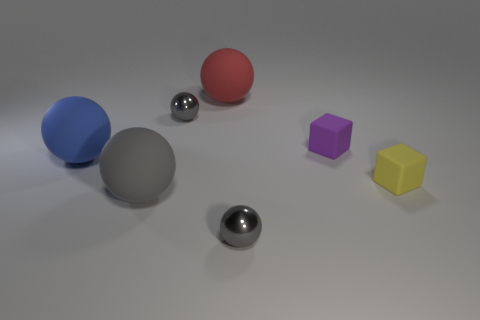Are there any small gray shiny balls in front of the big blue rubber thing?
Offer a very short reply. Yes. Is there any other thing that has the same size as the purple matte object?
Provide a short and direct response. Yes. What color is the other tiny block that is made of the same material as the tiny purple cube?
Offer a terse response. Yellow. Does the shiny ball in front of the big gray ball have the same color as the large object in front of the tiny yellow cube?
Give a very brief answer. Yes. What number of spheres are either big rubber things or small purple rubber things?
Offer a very short reply. 3. Is the number of large balls that are in front of the large blue thing the same as the number of small purple rubber blocks?
Offer a terse response. Yes. There is a tiny gray sphere to the left of the large matte thing that is behind the small gray shiny sphere behind the blue matte ball; what is its material?
Make the answer very short. Metal. How many things are big objects that are on the right side of the blue matte thing or blue rubber things?
Provide a succinct answer. 3. What number of things are either large spheres or tiny gray spheres to the right of the large red rubber thing?
Ensure brevity in your answer.  4. How many rubber things are in front of the tiny yellow cube to the right of the metal thing right of the red rubber sphere?
Make the answer very short. 1. 